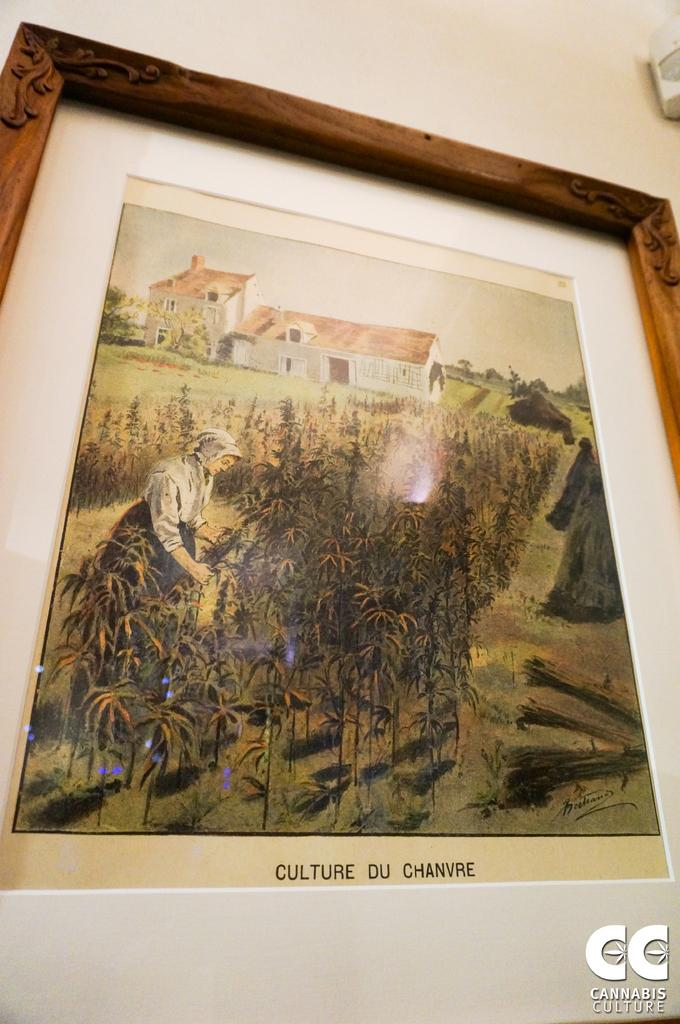<image>
Render a clear and concise summary of the photo. A framed painting is titled Culture du Chanvre. 